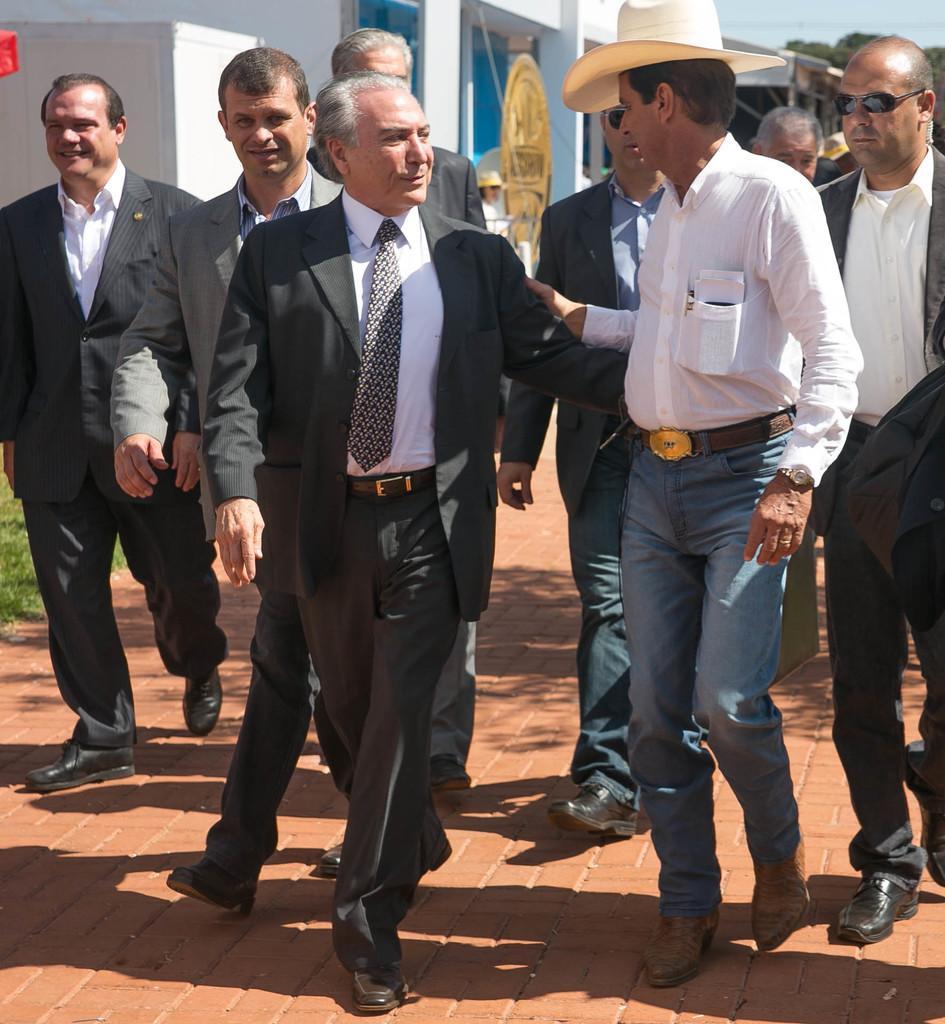Can you describe this image briefly? In this image, we can see people walking and some are wearing coats and one of them is wearing a hat. In the background, there are sheds and we can see trees. At the bottom, there are plants and there is a road. 